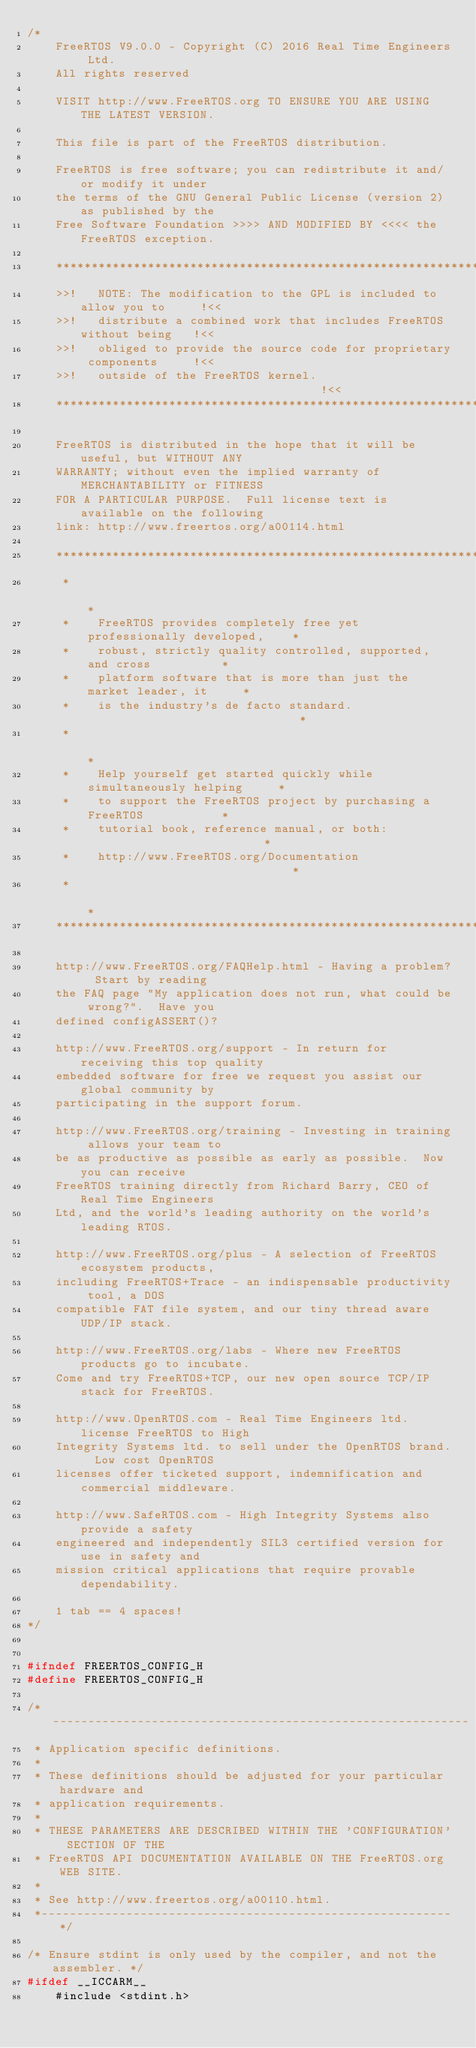<code> <loc_0><loc_0><loc_500><loc_500><_C_>/*
    FreeRTOS V9.0.0 - Copyright (C) 2016 Real Time Engineers Ltd.
    All rights reserved

    VISIT http://www.FreeRTOS.org TO ENSURE YOU ARE USING THE LATEST VERSION.

    This file is part of the FreeRTOS distribution.

    FreeRTOS is free software; you can redistribute it and/or modify it under
    the terms of the GNU General Public License (version 2) as published by the
    Free Software Foundation >>>> AND MODIFIED BY <<<< the FreeRTOS exception.

    ***************************************************************************
    >>!   NOTE: The modification to the GPL is included to allow you to     !<<
    >>!   distribute a combined work that includes FreeRTOS without being   !<<
    >>!   obliged to provide the source code for proprietary components     !<<
    >>!   outside of the FreeRTOS kernel.                                   !<<
    ***************************************************************************

    FreeRTOS is distributed in the hope that it will be useful, but WITHOUT ANY
    WARRANTY; without even the implied warranty of MERCHANTABILITY or FITNESS
    FOR A PARTICULAR PURPOSE.  Full license text is available on the following
    link: http://www.freertos.org/a00114.html

    ***************************************************************************
     *                                                                       *
     *    FreeRTOS provides completely free yet professionally developed,    *
     *    robust, strictly quality controlled, supported, and cross          *
     *    platform software that is more than just the market leader, it     *
     *    is the industry's de facto standard.                               *
     *                                                                       *
     *    Help yourself get started quickly while simultaneously helping     *
     *    to support the FreeRTOS project by purchasing a FreeRTOS           *
     *    tutorial book, reference manual, or both:                          *
     *    http://www.FreeRTOS.org/Documentation                              *
     *                                                                       *
    ***************************************************************************

    http://www.FreeRTOS.org/FAQHelp.html - Having a problem?  Start by reading
    the FAQ page "My application does not run, what could be wrong?".  Have you
    defined configASSERT()?

    http://www.FreeRTOS.org/support - In return for receiving this top quality
    embedded software for free we request you assist our global community by
    participating in the support forum.

    http://www.FreeRTOS.org/training - Investing in training allows your team to
    be as productive as possible as early as possible.  Now you can receive
    FreeRTOS training directly from Richard Barry, CEO of Real Time Engineers
    Ltd, and the world's leading authority on the world's leading RTOS.

    http://www.FreeRTOS.org/plus - A selection of FreeRTOS ecosystem products,
    including FreeRTOS+Trace - an indispensable productivity tool, a DOS
    compatible FAT file system, and our tiny thread aware UDP/IP stack.

    http://www.FreeRTOS.org/labs - Where new FreeRTOS products go to incubate.
    Come and try FreeRTOS+TCP, our new open source TCP/IP stack for FreeRTOS.

    http://www.OpenRTOS.com - Real Time Engineers ltd. license FreeRTOS to High
    Integrity Systems ltd. to sell under the OpenRTOS brand.  Low cost OpenRTOS
    licenses offer ticketed support, indemnification and commercial middleware.

    http://www.SafeRTOS.com - High Integrity Systems also provide a safety
    engineered and independently SIL3 certified version for use in safety and
    mission critical applications that require provable dependability.

    1 tab == 4 spaces!
*/


#ifndef FREERTOS_CONFIG_H
#define FREERTOS_CONFIG_H

/*-----------------------------------------------------------
 * Application specific definitions.
 *
 * These definitions should be adjusted for your particular hardware and
 * application requirements.
 *
 * THESE PARAMETERS ARE DESCRIBED WITHIN THE 'CONFIGURATION' SECTION OF THE
 * FreeRTOS API DOCUMENTATION AVAILABLE ON THE FreeRTOS.org WEB SITE.
 *
 * See http://www.freertos.org/a00110.html.
 *----------------------------------------------------------*/

/* Ensure stdint is only used by the compiler, and not the assembler. */
#ifdef __ICCARM__
	#include <stdint.h></code> 